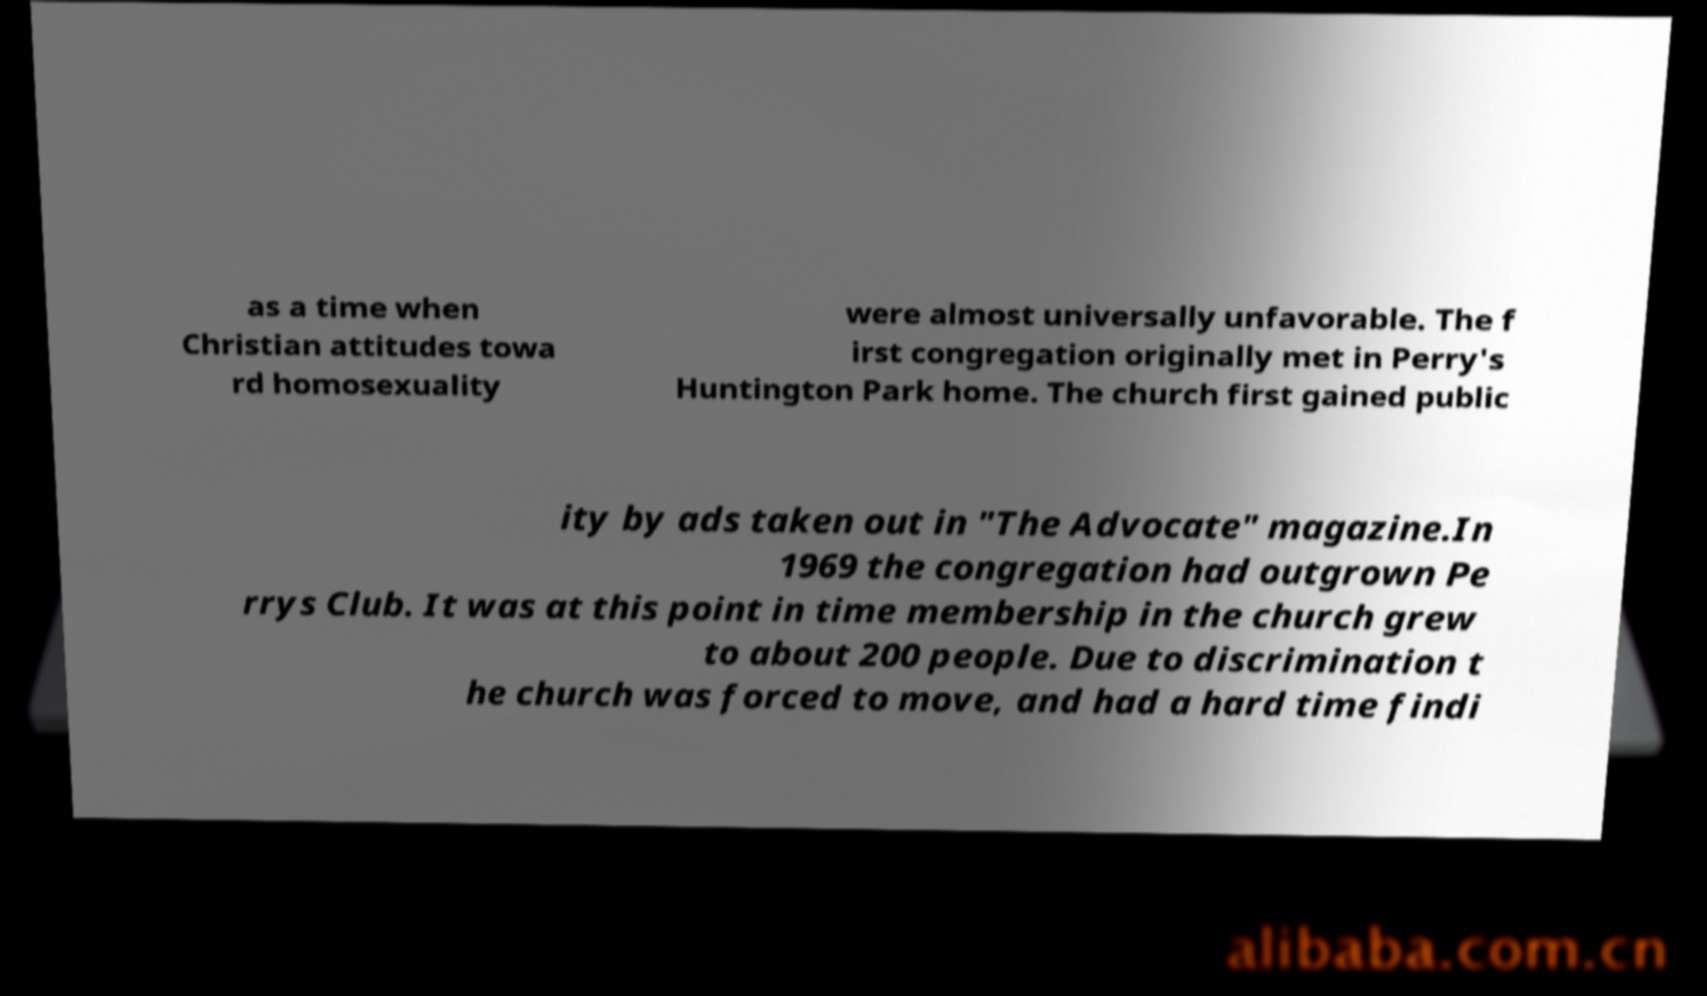Can you accurately transcribe the text from the provided image for me? as a time when Christian attitudes towa rd homosexuality were almost universally unfavorable. The f irst congregation originally met in Perry's Huntington Park home. The church first gained public ity by ads taken out in "The Advocate" magazine.In 1969 the congregation had outgrown Pe rrys Club. It was at this point in time membership in the church grew to about 200 people. Due to discrimination t he church was forced to move, and had a hard time findi 